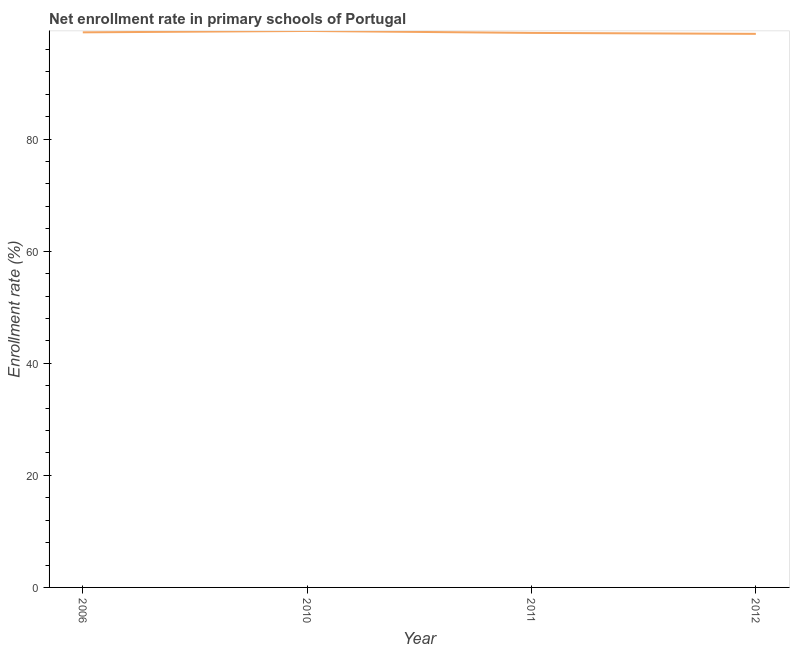What is the net enrollment rate in primary schools in 2011?
Provide a succinct answer. 98.96. Across all years, what is the maximum net enrollment rate in primary schools?
Provide a short and direct response. 99.3. Across all years, what is the minimum net enrollment rate in primary schools?
Provide a short and direct response. 98.79. In which year was the net enrollment rate in primary schools maximum?
Your answer should be compact. 2010. What is the sum of the net enrollment rate in primary schools?
Your answer should be very brief. 396.11. What is the difference between the net enrollment rate in primary schools in 2006 and 2010?
Offer a very short reply. -0.25. What is the average net enrollment rate in primary schools per year?
Offer a very short reply. 99.03. What is the median net enrollment rate in primary schools?
Ensure brevity in your answer.  99.01. In how many years, is the net enrollment rate in primary schools greater than 36 %?
Your response must be concise. 4. What is the ratio of the net enrollment rate in primary schools in 2011 to that in 2012?
Keep it short and to the point. 1. Is the net enrollment rate in primary schools in 2010 less than that in 2012?
Give a very brief answer. No. What is the difference between the highest and the second highest net enrollment rate in primary schools?
Offer a terse response. 0.25. What is the difference between the highest and the lowest net enrollment rate in primary schools?
Give a very brief answer. 0.52. In how many years, is the net enrollment rate in primary schools greater than the average net enrollment rate in primary schools taken over all years?
Your answer should be compact. 2. What is the difference between two consecutive major ticks on the Y-axis?
Provide a succinct answer. 20. Does the graph contain grids?
Your answer should be compact. No. What is the title of the graph?
Offer a very short reply. Net enrollment rate in primary schools of Portugal. What is the label or title of the Y-axis?
Your answer should be compact. Enrollment rate (%). What is the Enrollment rate (%) of 2006?
Give a very brief answer. 99.06. What is the Enrollment rate (%) of 2010?
Your answer should be very brief. 99.3. What is the Enrollment rate (%) in 2011?
Make the answer very short. 98.96. What is the Enrollment rate (%) of 2012?
Provide a short and direct response. 98.79. What is the difference between the Enrollment rate (%) in 2006 and 2010?
Provide a short and direct response. -0.25. What is the difference between the Enrollment rate (%) in 2006 and 2011?
Your answer should be very brief. 0.1. What is the difference between the Enrollment rate (%) in 2006 and 2012?
Keep it short and to the point. 0.27. What is the difference between the Enrollment rate (%) in 2010 and 2011?
Your answer should be very brief. 0.35. What is the difference between the Enrollment rate (%) in 2010 and 2012?
Provide a short and direct response. 0.52. What is the difference between the Enrollment rate (%) in 2011 and 2012?
Provide a short and direct response. 0.17. What is the ratio of the Enrollment rate (%) in 2010 to that in 2011?
Keep it short and to the point. 1. 